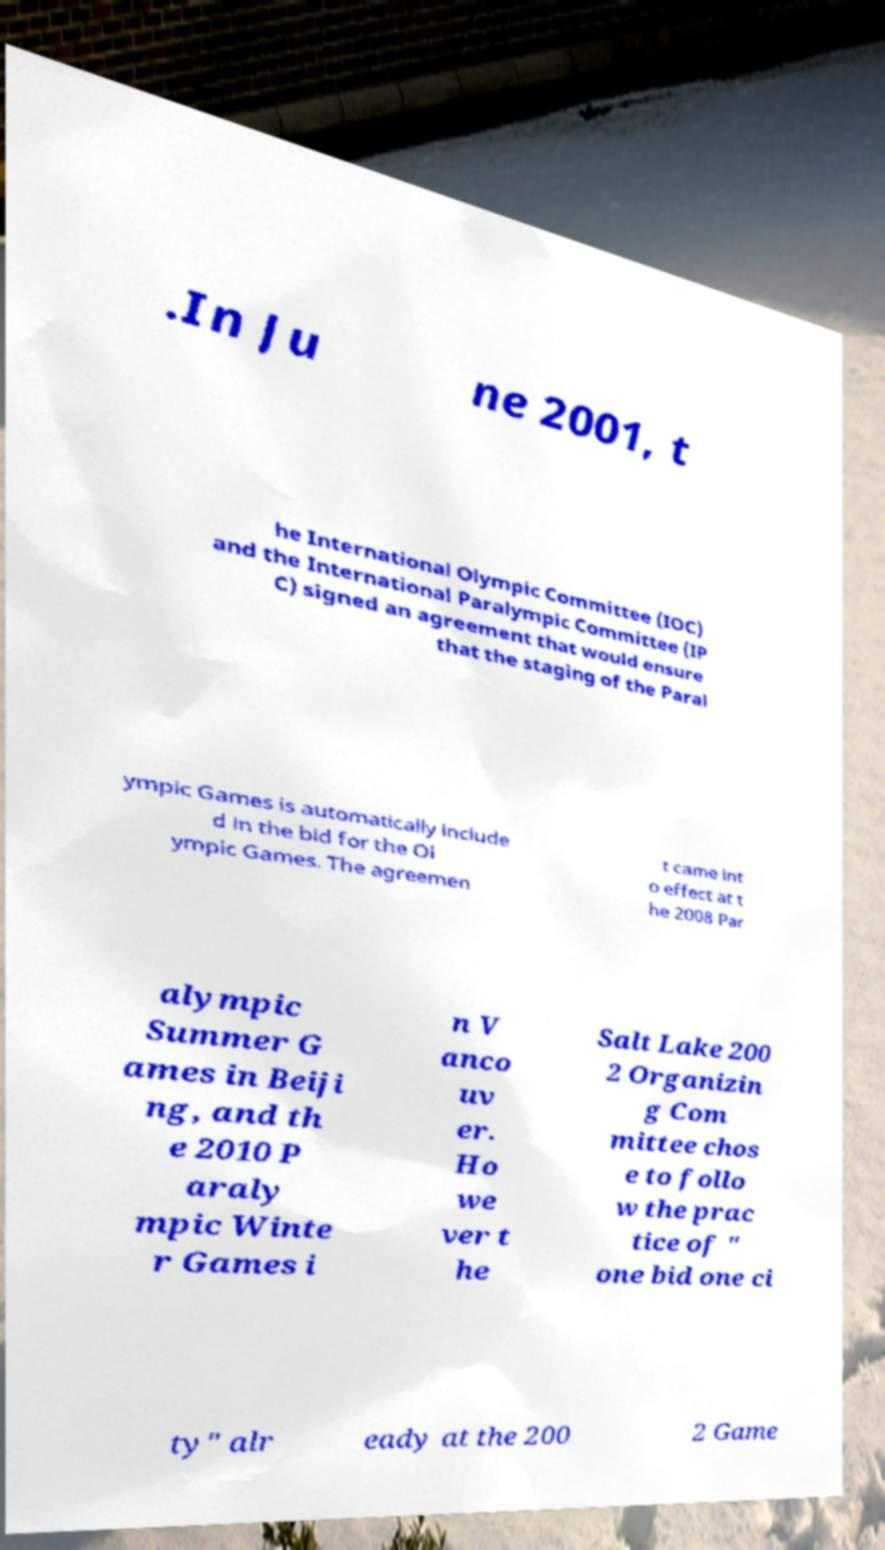Please read and relay the text visible in this image. What does it say? .In Ju ne 2001, t he International Olympic Committee (IOC) and the International Paralympic Committee (IP C) signed an agreement that would ensure that the staging of the Paral ympic Games is automatically include d in the bid for the Ol ympic Games. The agreemen t came int o effect at t he 2008 Par alympic Summer G ames in Beiji ng, and th e 2010 P araly mpic Winte r Games i n V anco uv er. Ho we ver t he Salt Lake 200 2 Organizin g Com mittee chos e to follo w the prac tice of " one bid one ci ty" alr eady at the 200 2 Game 